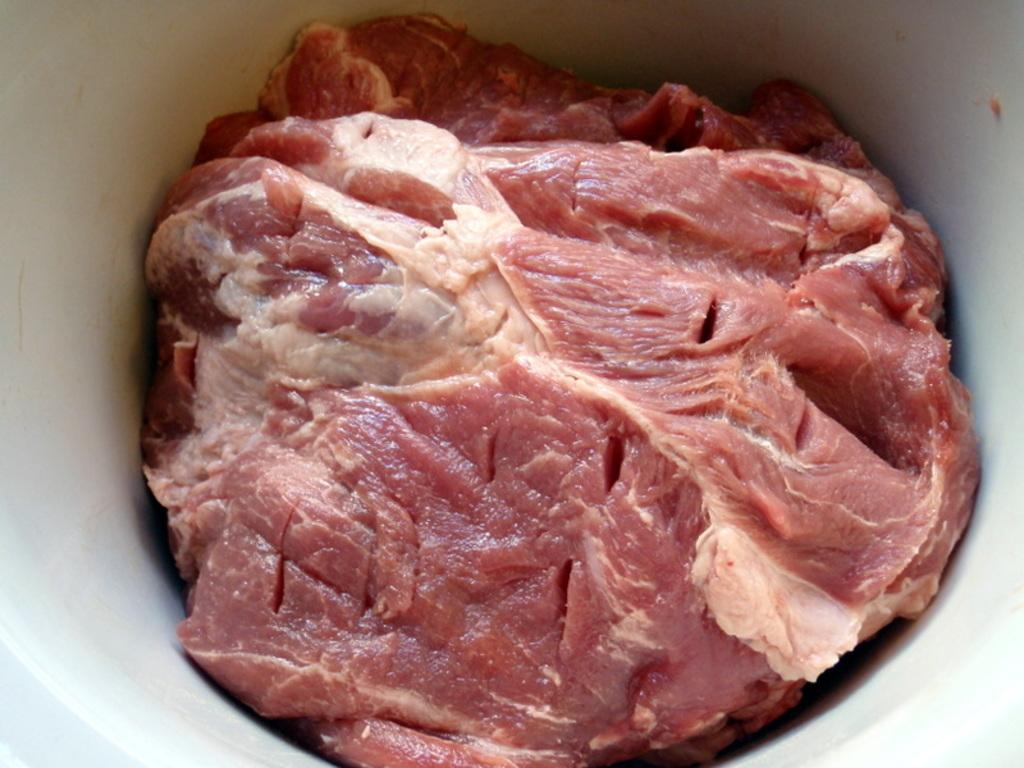What is the main subject in the image? There is a lump of meat in the image. Where is the meat located? The meat is in a bowl. How does the meat smile in the image? The meat does not smile in the image, as it is an inanimate object and cannot display emotions. 